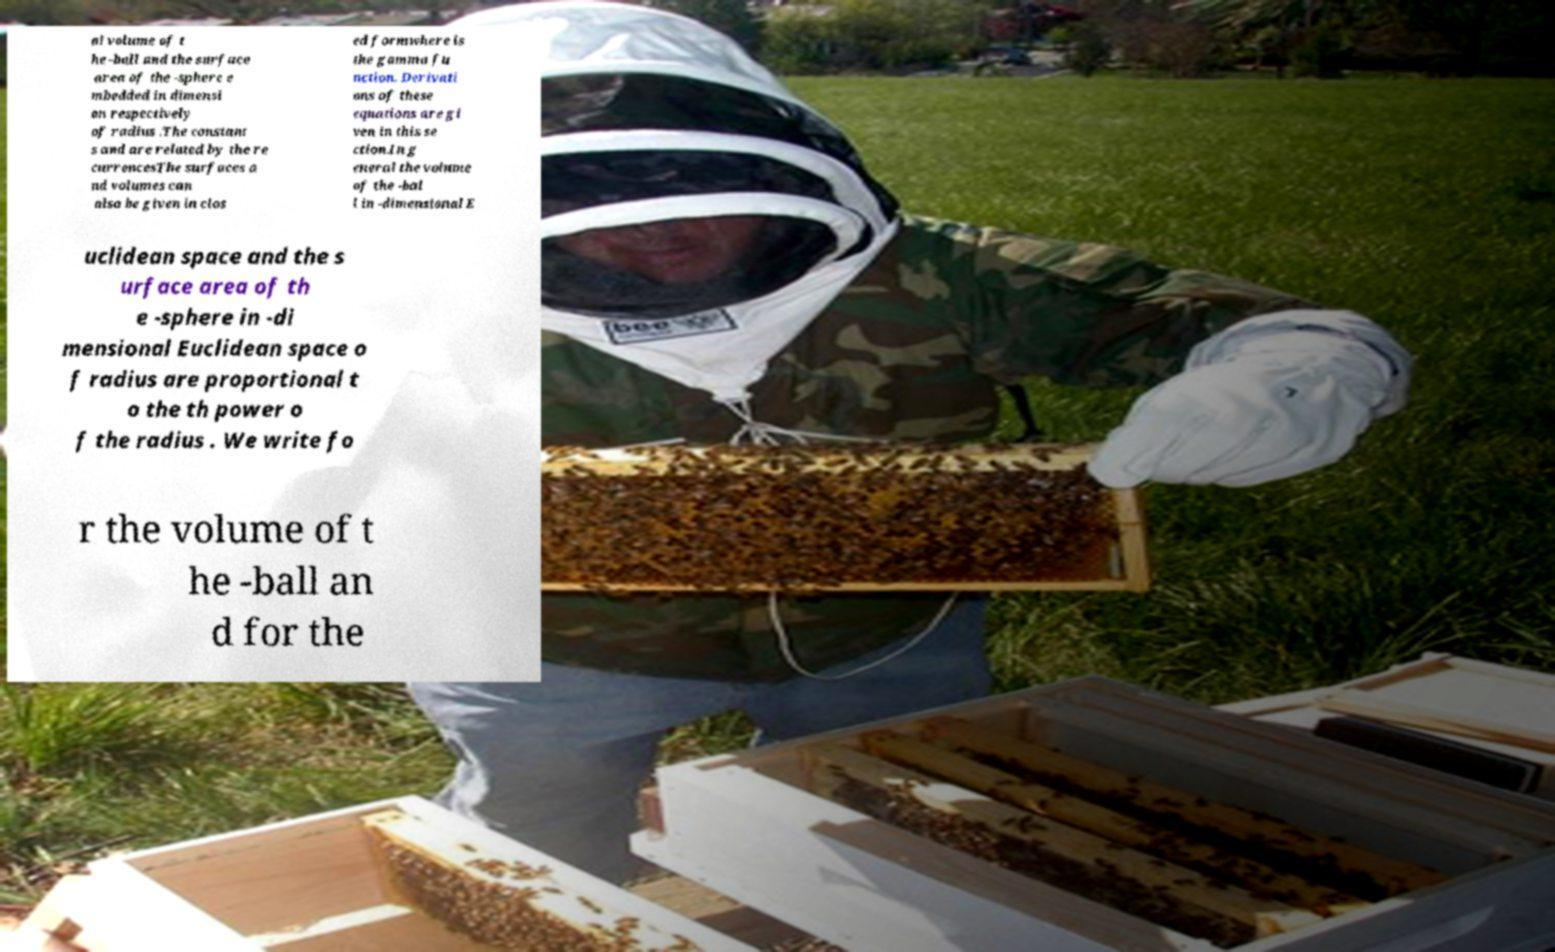Can you read and provide the text displayed in the image?This photo seems to have some interesting text. Can you extract and type it out for me? al volume of t he -ball and the surface area of the -sphere e mbedded in dimensi on respectively of radius .The constant s and are related by the re currencesThe surfaces a nd volumes can also be given in clos ed formwhere is the gamma fu nction. Derivati ons of these equations are gi ven in this se ction.In g eneral the volume of the -bal l in -dimensional E uclidean space and the s urface area of th e -sphere in -di mensional Euclidean space o f radius are proportional t o the th power o f the radius . We write fo r the volume of t he -ball an d for the 